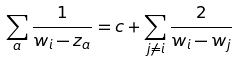Convert formula to latex. <formula><loc_0><loc_0><loc_500><loc_500>\sum _ { a } \frac { 1 } { w _ { i } - z _ { a } } = c + \sum _ { j \neq i } \frac { 2 } { w _ { i } - w _ { j } }</formula> 